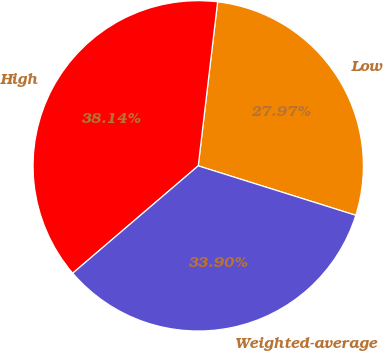<chart> <loc_0><loc_0><loc_500><loc_500><pie_chart><fcel>Low<fcel>High<fcel>Weighted-average<nl><fcel>27.97%<fcel>38.14%<fcel>33.9%<nl></chart> 